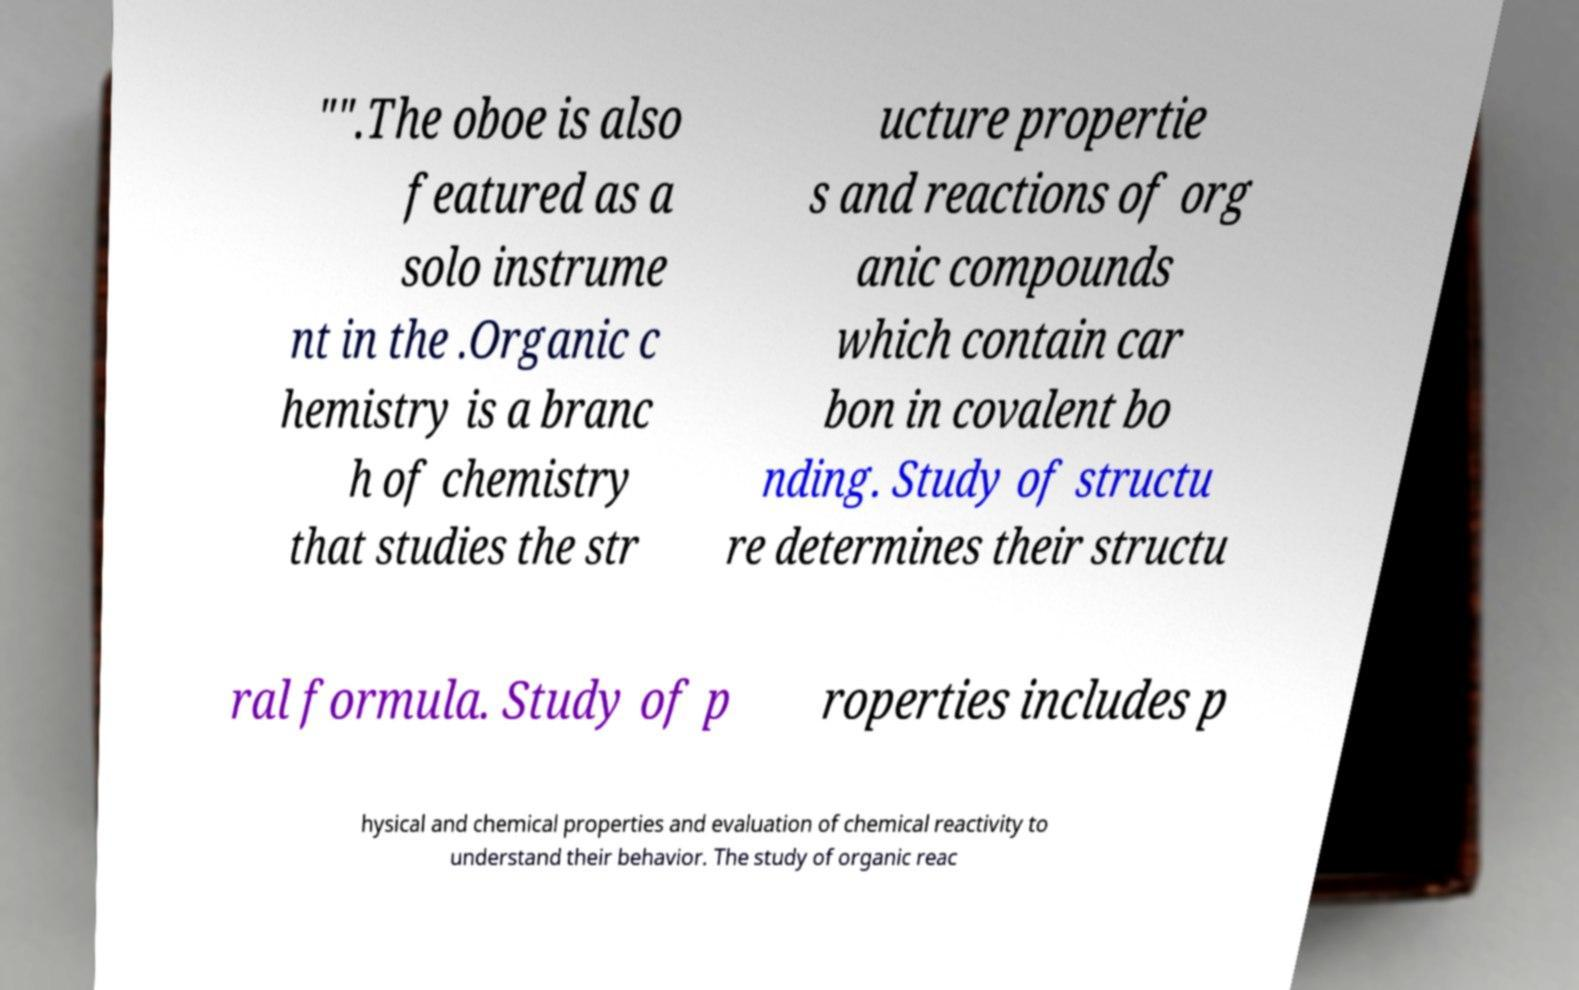What messages or text are displayed in this image? I need them in a readable, typed format. "".The oboe is also featured as a solo instrume nt in the .Organic c hemistry is a branc h of chemistry that studies the str ucture propertie s and reactions of org anic compounds which contain car bon in covalent bo nding. Study of structu re determines their structu ral formula. Study of p roperties includes p hysical and chemical properties and evaluation of chemical reactivity to understand their behavior. The study of organic reac 